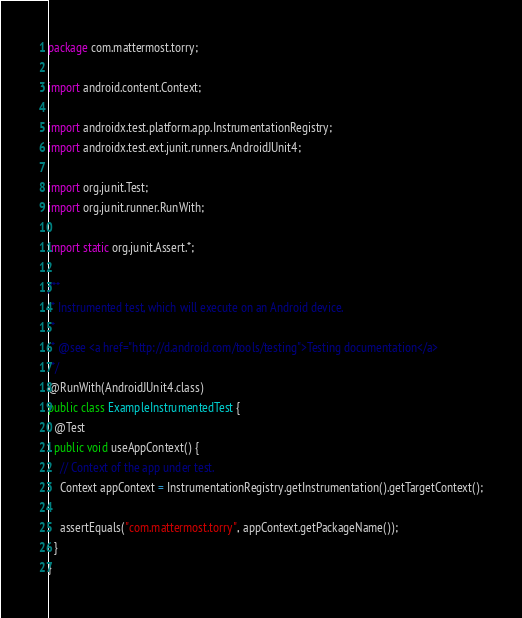Convert code to text. <code><loc_0><loc_0><loc_500><loc_500><_Java_>package com.mattermost.torry;

import android.content.Context;

import androidx.test.platform.app.InstrumentationRegistry;
import androidx.test.ext.junit.runners.AndroidJUnit4;

import org.junit.Test;
import org.junit.runner.RunWith;

import static org.junit.Assert.*;

/**
 * Instrumented test, which will execute on an Android device.
 *
 * @see <a href="http://d.android.com/tools/testing">Testing documentation</a>
 */
@RunWith(AndroidJUnit4.class)
public class ExampleInstrumentedTest {
  @Test
  public void useAppContext() {
    // Context of the app under test.
    Context appContext = InstrumentationRegistry.getInstrumentation().getTargetContext();

    assertEquals("com.mattermost.torry", appContext.getPackageName());
  }
}
</code> 